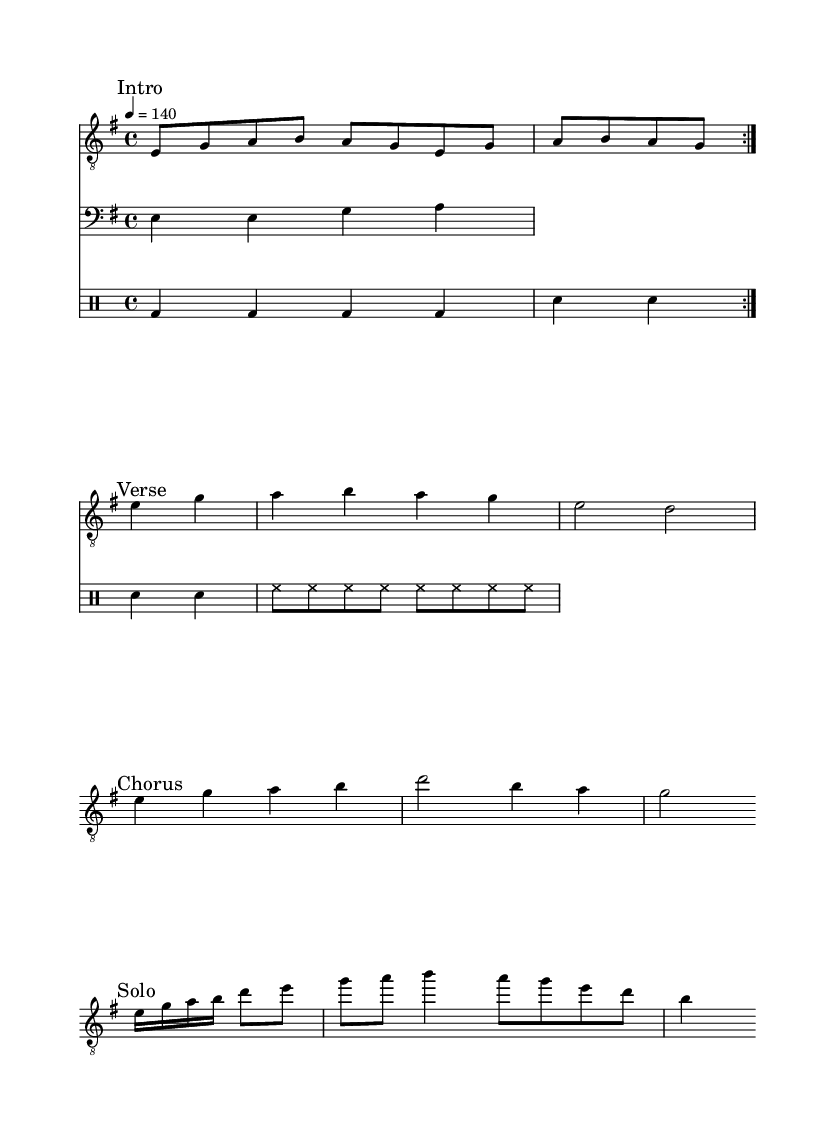What is the key signature of this music? The key signature indicated on the left of the staff shows a single sharp, which defines the piece as in E minor.
Answer: E minor What is the time signature of this music? The time signature is displayed at the beginning of the piece as 4/4, indicating that there are four beats in each measure and the quarter note gets one beat.
Answer: 4/4 What is the tempo marking for this music? The tempo marking of the piece states "4 = 140", meaning there are 140 beats per minute, which is a fairly fast pace for metal music.
Answer: 140 What section comes after the verse? The structure of the music specifies the flow, and the first section that follows the verse is marked "Chorus".
Answer: Chorus How many measures are in the guitar solo? By counting the number of measures indicated by the guitar solo notation, we can see that it lasts for four measures.
Answer: 4 What type of instrument is the drums part written for? The drums part is noted under a "DrumStaff" which specifically denotes that it is meant for a percussion section, specifically drums.
Answer: Percussion What is the seventh note in the guitar verse? Referring to the notes in the guitar verse section, the seventh note is "D," located after the fifth note "G" in the sequence.
Answer: D 